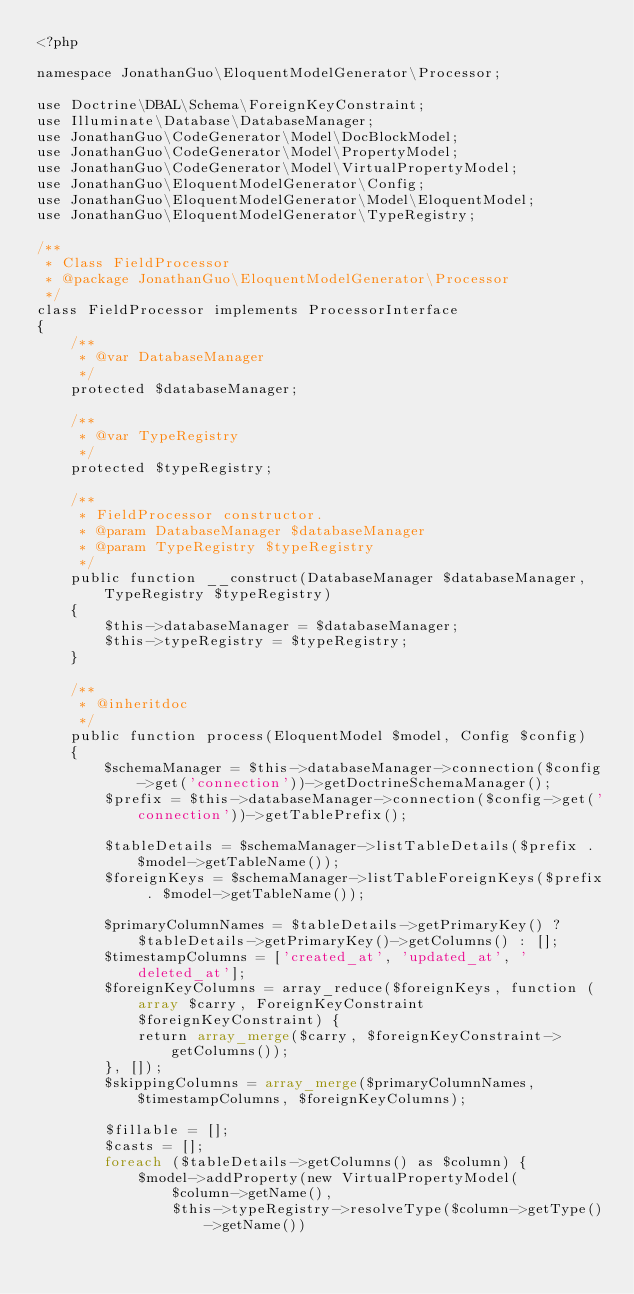<code> <loc_0><loc_0><loc_500><loc_500><_PHP_><?php

namespace JonathanGuo\EloquentModelGenerator\Processor;

use Doctrine\DBAL\Schema\ForeignKeyConstraint;
use Illuminate\Database\DatabaseManager;
use JonathanGuo\CodeGenerator\Model\DocBlockModel;
use JonathanGuo\CodeGenerator\Model\PropertyModel;
use JonathanGuo\CodeGenerator\Model\VirtualPropertyModel;
use JonathanGuo\EloquentModelGenerator\Config;
use JonathanGuo\EloquentModelGenerator\Model\EloquentModel;
use JonathanGuo\EloquentModelGenerator\TypeRegistry;

/**
 * Class FieldProcessor
 * @package JonathanGuo\EloquentModelGenerator\Processor
 */
class FieldProcessor implements ProcessorInterface
{
    /**
     * @var DatabaseManager
     */
    protected $databaseManager;

    /**
     * @var TypeRegistry
     */
    protected $typeRegistry;

    /**
     * FieldProcessor constructor.
     * @param DatabaseManager $databaseManager
     * @param TypeRegistry $typeRegistry
     */
    public function __construct(DatabaseManager $databaseManager, TypeRegistry $typeRegistry)
    {
        $this->databaseManager = $databaseManager;
        $this->typeRegistry = $typeRegistry;
    }

    /**
     * @inheritdoc
     */
    public function process(EloquentModel $model, Config $config)
    {
        $schemaManager = $this->databaseManager->connection($config->get('connection'))->getDoctrineSchemaManager();
        $prefix = $this->databaseManager->connection($config->get('connection'))->getTablePrefix();

        $tableDetails = $schemaManager->listTableDetails($prefix . $model->getTableName());
        $foreignKeys = $schemaManager->listTableForeignKeys($prefix . $model->getTableName());

        $primaryColumnNames = $tableDetails->getPrimaryKey() ? $tableDetails->getPrimaryKey()->getColumns() : [];
        $timestampColumns = ['created_at', 'updated_at', 'deleted_at'];
        $foreignKeyColumns = array_reduce($foreignKeys, function (array $carry, ForeignKeyConstraint $foreignKeyConstraint) {
            return array_merge($carry, $foreignKeyConstraint->getColumns());
        }, []);
        $skippingColumns = array_merge($primaryColumnNames, $timestampColumns, $foreignKeyColumns);

        $fillable = [];
        $casts = [];
        foreach ($tableDetails->getColumns() as $column) {
            $model->addProperty(new VirtualPropertyModel(
                $column->getName(),
                $this->typeRegistry->resolveType($column->getType()->getName())</code> 